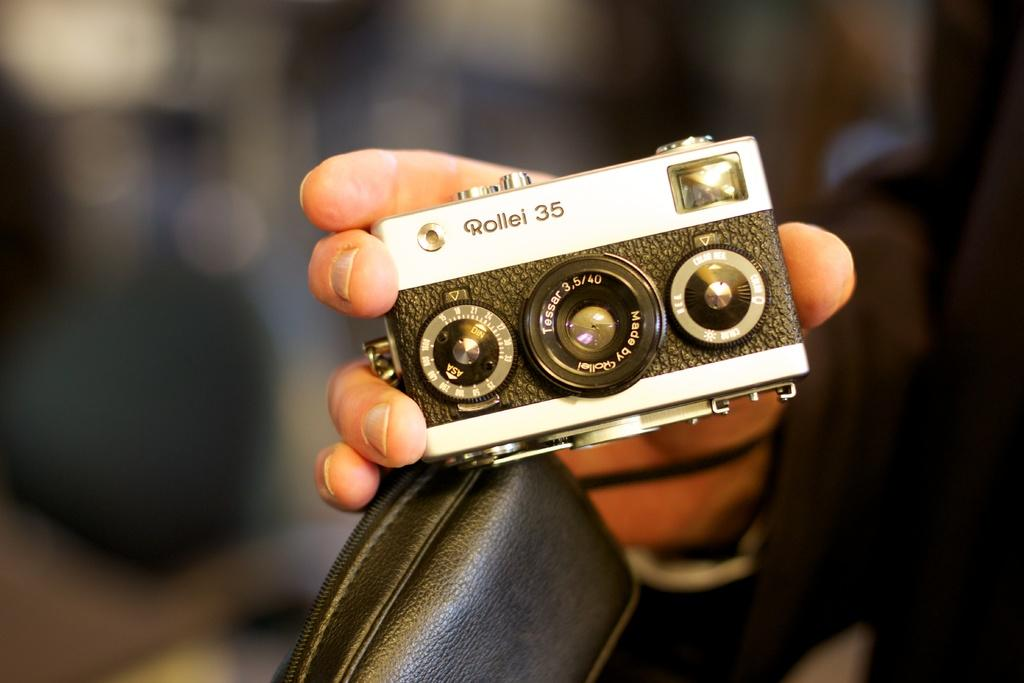Provide a one-sentence caption for the provided image. Person holding a mini camera that says Rollel 35 on it. 